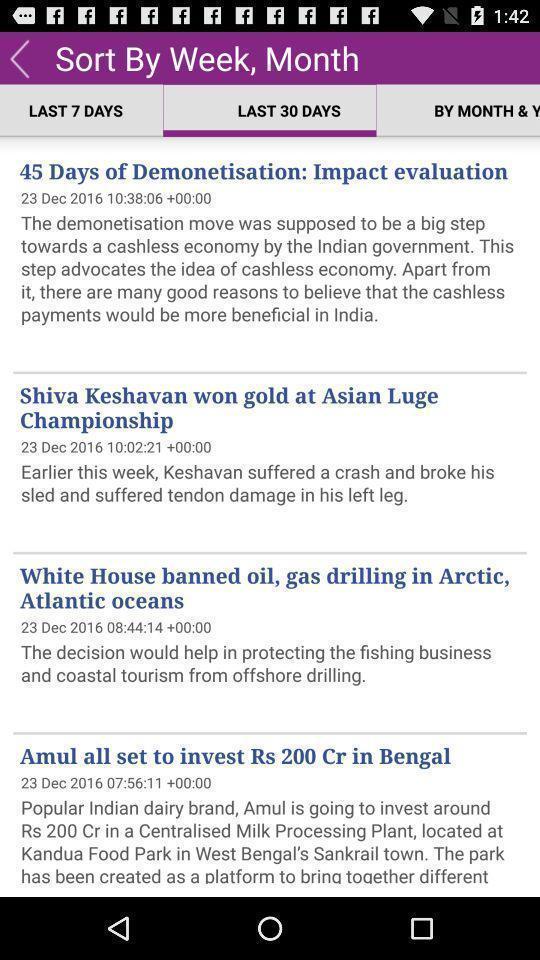Provide a textual representation of this image. Showing last 30 days news details in a study app. 